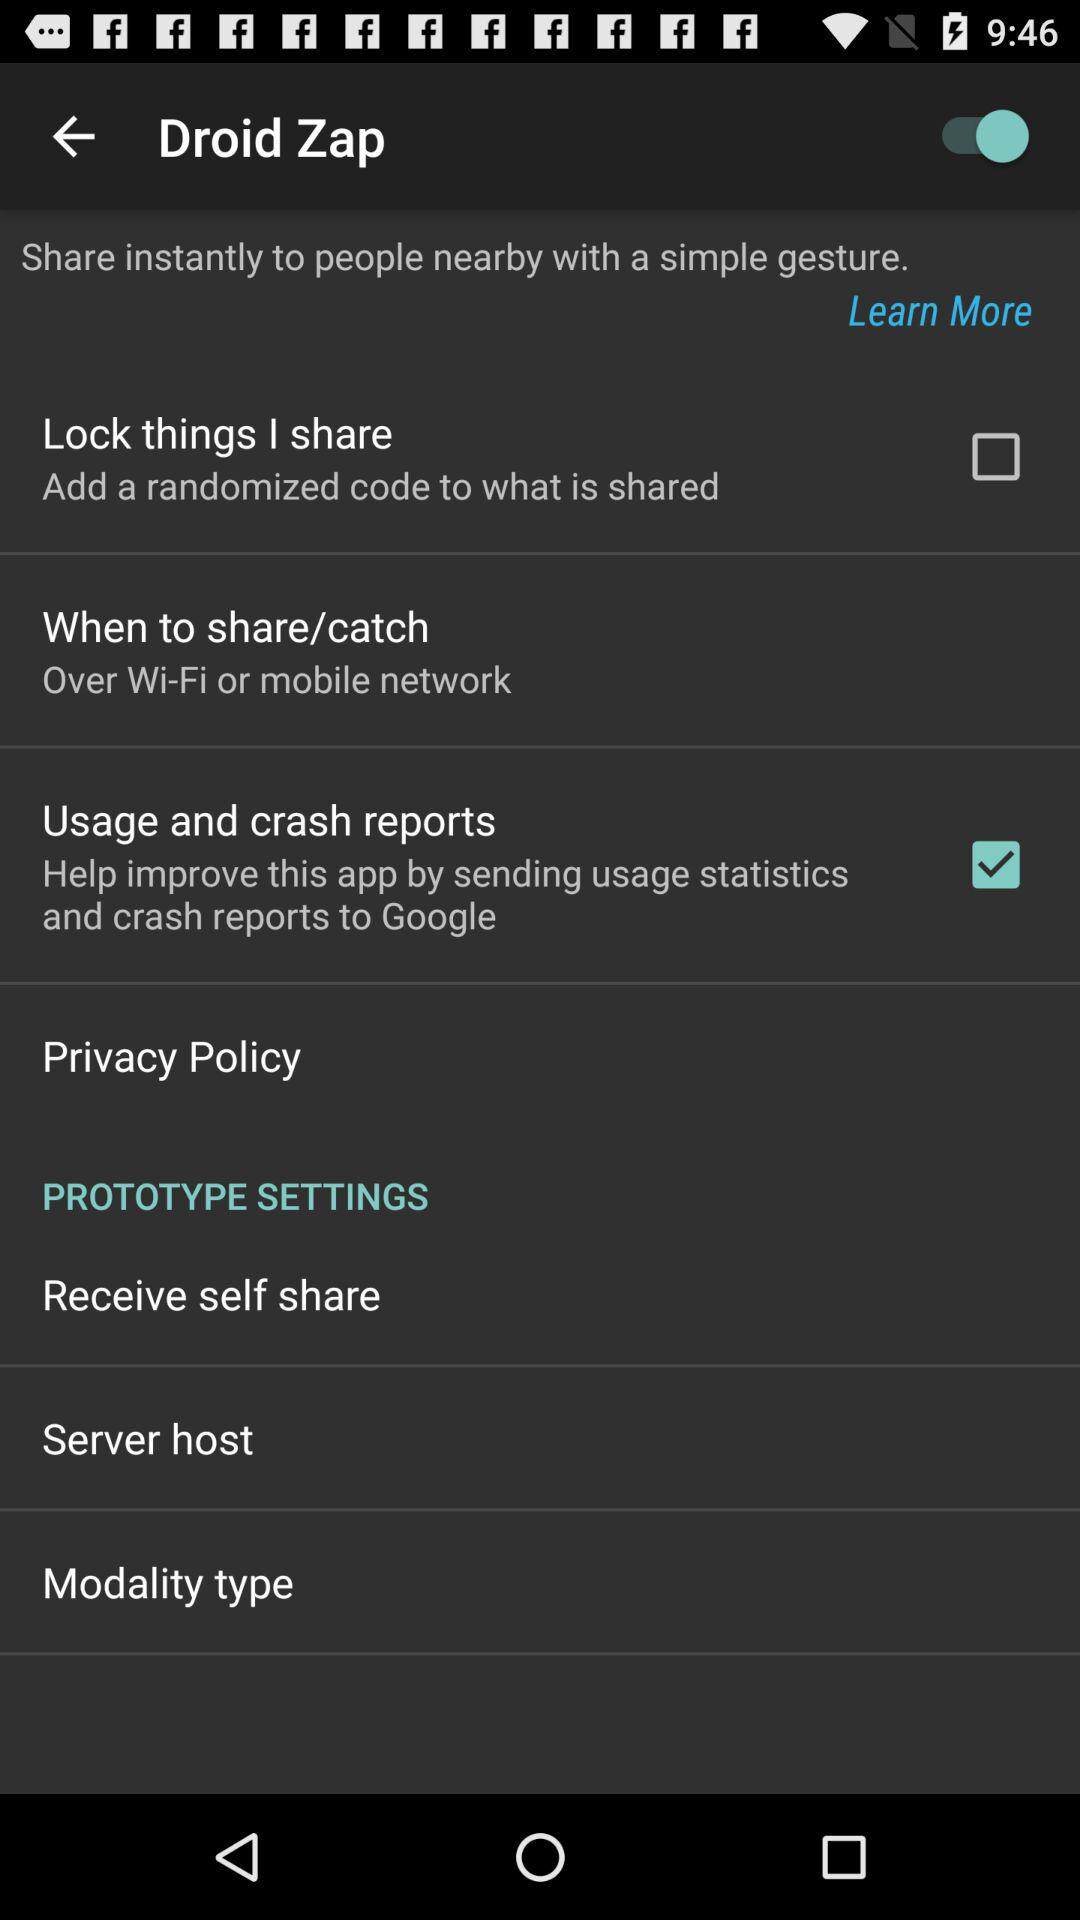What is the status of "Usage and crash reports"? The status of "Usage and crash reports" is "on". 